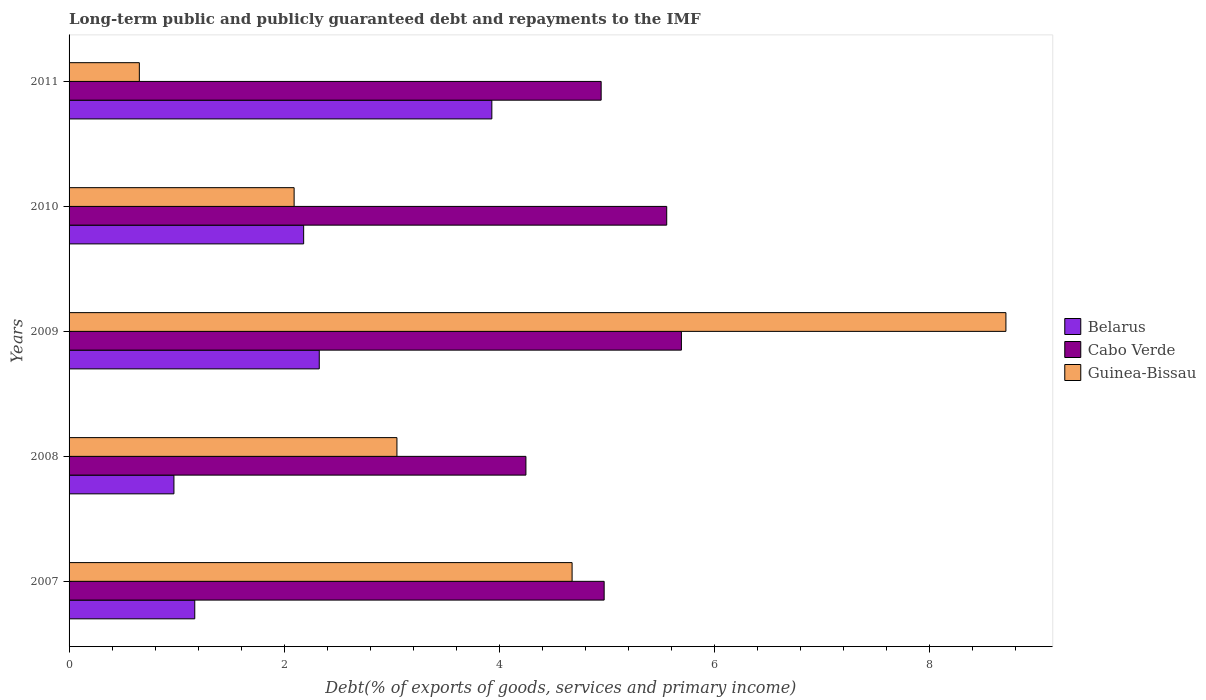How many different coloured bars are there?
Your answer should be compact. 3. How many groups of bars are there?
Ensure brevity in your answer.  5. Are the number of bars per tick equal to the number of legend labels?
Provide a succinct answer. Yes. In how many cases, is the number of bars for a given year not equal to the number of legend labels?
Keep it short and to the point. 0. What is the debt and repayments in Guinea-Bissau in 2007?
Keep it short and to the point. 4.68. Across all years, what is the maximum debt and repayments in Belarus?
Offer a very short reply. 3.93. Across all years, what is the minimum debt and repayments in Cabo Verde?
Your answer should be very brief. 4.25. In which year was the debt and repayments in Belarus maximum?
Make the answer very short. 2011. In which year was the debt and repayments in Belarus minimum?
Your response must be concise. 2008. What is the total debt and repayments in Belarus in the graph?
Provide a short and direct response. 10.58. What is the difference between the debt and repayments in Cabo Verde in 2010 and that in 2011?
Keep it short and to the point. 0.61. What is the difference between the debt and repayments in Cabo Verde in 2011 and the debt and repayments in Guinea-Bissau in 2008?
Give a very brief answer. 1.9. What is the average debt and repayments in Cabo Verde per year?
Ensure brevity in your answer.  5.08. In the year 2011, what is the difference between the debt and repayments in Belarus and debt and repayments in Guinea-Bissau?
Give a very brief answer. 3.28. In how many years, is the debt and repayments in Guinea-Bissau greater than 1.6 %?
Make the answer very short. 4. What is the ratio of the debt and repayments in Cabo Verde in 2007 to that in 2009?
Your answer should be very brief. 0.87. What is the difference between the highest and the second highest debt and repayments in Belarus?
Your answer should be compact. 1.6. What is the difference between the highest and the lowest debt and repayments in Belarus?
Make the answer very short. 2.96. In how many years, is the debt and repayments in Belarus greater than the average debt and repayments in Belarus taken over all years?
Offer a very short reply. 3. What does the 2nd bar from the top in 2008 represents?
Give a very brief answer. Cabo Verde. What does the 3rd bar from the bottom in 2007 represents?
Your answer should be very brief. Guinea-Bissau. How many bars are there?
Keep it short and to the point. 15. How many years are there in the graph?
Give a very brief answer. 5. Are the values on the major ticks of X-axis written in scientific E-notation?
Give a very brief answer. No. Does the graph contain any zero values?
Your response must be concise. No. Does the graph contain grids?
Keep it short and to the point. No. How many legend labels are there?
Provide a succinct answer. 3. What is the title of the graph?
Offer a very short reply. Long-term public and publicly guaranteed debt and repayments to the IMF. Does "United Kingdom" appear as one of the legend labels in the graph?
Your response must be concise. No. What is the label or title of the X-axis?
Your answer should be compact. Debt(% of exports of goods, services and primary income). What is the Debt(% of exports of goods, services and primary income) of Belarus in 2007?
Ensure brevity in your answer.  1.17. What is the Debt(% of exports of goods, services and primary income) in Cabo Verde in 2007?
Your answer should be very brief. 4.97. What is the Debt(% of exports of goods, services and primary income) in Guinea-Bissau in 2007?
Offer a terse response. 4.68. What is the Debt(% of exports of goods, services and primary income) in Belarus in 2008?
Provide a succinct answer. 0.98. What is the Debt(% of exports of goods, services and primary income) in Cabo Verde in 2008?
Give a very brief answer. 4.25. What is the Debt(% of exports of goods, services and primary income) in Guinea-Bissau in 2008?
Provide a short and direct response. 3.05. What is the Debt(% of exports of goods, services and primary income) in Belarus in 2009?
Your response must be concise. 2.33. What is the Debt(% of exports of goods, services and primary income) of Cabo Verde in 2009?
Your answer should be compact. 5.69. What is the Debt(% of exports of goods, services and primary income) in Guinea-Bissau in 2009?
Provide a short and direct response. 8.71. What is the Debt(% of exports of goods, services and primary income) of Belarus in 2010?
Ensure brevity in your answer.  2.18. What is the Debt(% of exports of goods, services and primary income) of Cabo Verde in 2010?
Ensure brevity in your answer.  5.56. What is the Debt(% of exports of goods, services and primary income) of Guinea-Bissau in 2010?
Ensure brevity in your answer.  2.09. What is the Debt(% of exports of goods, services and primary income) in Belarus in 2011?
Give a very brief answer. 3.93. What is the Debt(% of exports of goods, services and primary income) of Cabo Verde in 2011?
Offer a terse response. 4.95. What is the Debt(% of exports of goods, services and primary income) of Guinea-Bissau in 2011?
Provide a succinct answer. 0.65. Across all years, what is the maximum Debt(% of exports of goods, services and primary income) in Belarus?
Provide a short and direct response. 3.93. Across all years, what is the maximum Debt(% of exports of goods, services and primary income) of Cabo Verde?
Make the answer very short. 5.69. Across all years, what is the maximum Debt(% of exports of goods, services and primary income) in Guinea-Bissau?
Give a very brief answer. 8.71. Across all years, what is the minimum Debt(% of exports of goods, services and primary income) in Belarus?
Make the answer very short. 0.98. Across all years, what is the minimum Debt(% of exports of goods, services and primary income) of Cabo Verde?
Your answer should be compact. 4.25. Across all years, what is the minimum Debt(% of exports of goods, services and primary income) of Guinea-Bissau?
Offer a terse response. 0.65. What is the total Debt(% of exports of goods, services and primary income) in Belarus in the graph?
Offer a terse response. 10.58. What is the total Debt(% of exports of goods, services and primary income) of Cabo Verde in the graph?
Make the answer very short. 25.42. What is the total Debt(% of exports of goods, services and primary income) of Guinea-Bissau in the graph?
Provide a succinct answer. 19.18. What is the difference between the Debt(% of exports of goods, services and primary income) of Belarus in 2007 and that in 2008?
Your answer should be compact. 0.19. What is the difference between the Debt(% of exports of goods, services and primary income) in Cabo Verde in 2007 and that in 2008?
Your answer should be compact. 0.73. What is the difference between the Debt(% of exports of goods, services and primary income) of Guinea-Bissau in 2007 and that in 2008?
Ensure brevity in your answer.  1.63. What is the difference between the Debt(% of exports of goods, services and primary income) in Belarus in 2007 and that in 2009?
Make the answer very short. -1.16. What is the difference between the Debt(% of exports of goods, services and primary income) in Cabo Verde in 2007 and that in 2009?
Give a very brief answer. -0.72. What is the difference between the Debt(% of exports of goods, services and primary income) in Guinea-Bissau in 2007 and that in 2009?
Provide a succinct answer. -4.03. What is the difference between the Debt(% of exports of goods, services and primary income) of Belarus in 2007 and that in 2010?
Your answer should be very brief. -1.01. What is the difference between the Debt(% of exports of goods, services and primary income) of Cabo Verde in 2007 and that in 2010?
Offer a terse response. -0.58. What is the difference between the Debt(% of exports of goods, services and primary income) of Guinea-Bissau in 2007 and that in 2010?
Keep it short and to the point. 2.58. What is the difference between the Debt(% of exports of goods, services and primary income) in Belarus in 2007 and that in 2011?
Your answer should be very brief. -2.76. What is the difference between the Debt(% of exports of goods, services and primary income) of Cabo Verde in 2007 and that in 2011?
Provide a short and direct response. 0.03. What is the difference between the Debt(% of exports of goods, services and primary income) in Guinea-Bissau in 2007 and that in 2011?
Your answer should be very brief. 4.02. What is the difference between the Debt(% of exports of goods, services and primary income) of Belarus in 2008 and that in 2009?
Offer a very short reply. -1.35. What is the difference between the Debt(% of exports of goods, services and primary income) in Cabo Verde in 2008 and that in 2009?
Provide a succinct answer. -1.45. What is the difference between the Debt(% of exports of goods, services and primary income) of Guinea-Bissau in 2008 and that in 2009?
Provide a succinct answer. -5.66. What is the difference between the Debt(% of exports of goods, services and primary income) of Belarus in 2008 and that in 2010?
Provide a succinct answer. -1.21. What is the difference between the Debt(% of exports of goods, services and primary income) in Cabo Verde in 2008 and that in 2010?
Your response must be concise. -1.31. What is the difference between the Debt(% of exports of goods, services and primary income) in Guinea-Bissau in 2008 and that in 2010?
Provide a succinct answer. 0.96. What is the difference between the Debt(% of exports of goods, services and primary income) of Belarus in 2008 and that in 2011?
Offer a terse response. -2.96. What is the difference between the Debt(% of exports of goods, services and primary income) of Cabo Verde in 2008 and that in 2011?
Your response must be concise. -0.7. What is the difference between the Debt(% of exports of goods, services and primary income) of Guinea-Bissau in 2008 and that in 2011?
Your answer should be very brief. 2.39. What is the difference between the Debt(% of exports of goods, services and primary income) of Belarus in 2009 and that in 2010?
Your response must be concise. 0.15. What is the difference between the Debt(% of exports of goods, services and primary income) in Cabo Verde in 2009 and that in 2010?
Your answer should be compact. 0.14. What is the difference between the Debt(% of exports of goods, services and primary income) in Guinea-Bissau in 2009 and that in 2010?
Your response must be concise. 6.62. What is the difference between the Debt(% of exports of goods, services and primary income) of Belarus in 2009 and that in 2011?
Make the answer very short. -1.6. What is the difference between the Debt(% of exports of goods, services and primary income) of Cabo Verde in 2009 and that in 2011?
Make the answer very short. 0.75. What is the difference between the Debt(% of exports of goods, services and primary income) in Guinea-Bissau in 2009 and that in 2011?
Make the answer very short. 8.06. What is the difference between the Debt(% of exports of goods, services and primary income) in Belarus in 2010 and that in 2011?
Your answer should be very brief. -1.75. What is the difference between the Debt(% of exports of goods, services and primary income) in Cabo Verde in 2010 and that in 2011?
Give a very brief answer. 0.61. What is the difference between the Debt(% of exports of goods, services and primary income) in Guinea-Bissau in 2010 and that in 2011?
Provide a succinct answer. 1.44. What is the difference between the Debt(% of exports of goods, services and primary income) in Belarus in 2007 and the Debt(% of exports of goods, services and primary income) in Cabo Verde in 2008?
Keep it short and to the point. -3.08. What is the difference between the Debt(% of exports of goods, services and primary income) of Belarus in 2007 and the Debt(% of exports of goods, services and primary income) of Guinea-Bissau in 2008?
Offer a very short reply. -1.88. What is the difference between the Debt(% of exports of goods, services and primary income) in Cabo Verde in 2007 and the Debt(% of exports of goods, services and primary income) in Guinea-Bissau in 2008?
Your response must be concise. 1.93. What is the difference between the Debt(% of exports of goods, services and primary income) in Belarus in 2007 and the Debt(% of exports of goods, services and primary income) in Cabo Verde in 2009?
Provide a short and direct response. -4.52. What is the difference between the Debt(% of exports of goods, services and primary income) of Belarus in 2007 and the Debt(% of exports of goods, services and primary income) of Guinea-Bissau in 2009?
Offer a very short reply. -7.54. What is the difference between the Debt(% of exports of goods, services and primary income) of Cabo Verde in 2007 and the Debt(% of exports of goods, services and primary income) of Guinea-Bissau in 2009?
Offer a very short reply. -3.74. What is the difference between the Debt(% of exports of goods, services and primary income) of Belarus in 2007 and the Debt(% of exports of goods, services and primary income) of Cabo Verde in 2010?
Make the answer very short. -4.39. What is the difference between the Debt(% of exports of goods, services and primary income) in Belarus in 2007 and the Debt(% of exports of goods, services and primary income) in Guinea-Bissau in 2010?
Make the answer very short. -0.92. What is the difference between the Debt(% of exports of goods, services and primary income) in Cabo Verde in 2007 and the Debt(% of exports of goods, services and primary income) in Guinea-Bissau in 2010?
Give a very brief answer. 2.88. What is the difference between the Debt(% of exports of goods, services and primary income) in Belarus in 2007 and the Debt(% of exports of goods, services and primary income) in Cabo Verde in 2011?
Your response must be concise. -3.78. What is the difference between the Debt(% of exports of goods, services and primary income) in Belarus in 2007 and the Debt(% of exports of goods, services and primary income) in Guinea-Bissau in 2011?
Provide a succinct answer. 0.52. What is the difference between the Debt(% of exports of goods, services and primary income) of Cabo Verde in 2007 and the Debt(% of exports of goods, services and primary income) of Guinea-Bissau in 2011?
Make the answer very short. 4.32. What is the difference between the Debt(% of exports of goods, services and primary income) of Belarus in 2008 and the Debt(% of exports of goods, services and primary income) of Cabo Verde in 2009?
Offer a terse response. -4.72. What is the difference between the Debt(% of exports of goods, services and primary income) in Belarus in 2008 and the Debt(% of exports of goods, services and primary income) in Guinea-Bissau in 2009?
Offer a very short reply. -7.74. What is the difference between the Debt(% of exports of goods, services and primary income) in Cabo Verde in 2008 and the Debt(% of exports of goods, services and primary income) in Guinea-Bissau in 2009?
Your answer should be very brief. -4.46. What is the difference between the Debt(% of exports of goods, services and primary income) of Belarus in 2008 and the Debt(% of exports of goods, services and primary income) of Cabo Verde in 2010?
Keep it short and to the point. -4.58. What is the difference between the Debt(% of exports of goods, services and primary income) in Belarus in 2008 and the Debt(% of exports of goods, services and primary income) in Guinea-Bissau in 2010?
Provide a short and direct response. -1.12. What is the difference between the Debt(% of exports of goods, services and primary income) in Cabo Verde in 2008 and the Debt(% of exports of goods, services and primary income) in Guinea-Bissau in 2010?
Offer a very short reply. 2.15. What is the difference between the Debt(% of exports of goods, services and primary income) of Belarus in 2008 and the Debt(% of exports of goods, services and primary income) of Cabo Verde in 2011?
Keep it short and to the point. -3.97. What is the difference between the Debt(% of exports of goods, services and primary income) of Belarus in 2008 and the Debt(% of exports of goods, services and primary income) of Guinea-Bissau in 2011?
Give a very brief answer. 0.32. What is the difference between the Debt(% of exports of goods, services and primary income) of Cabo Verde in 2008 and the Debt(% of exports of goods, services and primary income) of Guinea-Bissau in 2011?
Give a very brief answer. 3.59. What is the difference between the Debt(% of exports of goods, services and primary income) of Belarus in 2009 and the Debt(% of exports of goods, services and primary income) of Cabo Verde in 2010?
Offer a terse response. -3.23. What is the difference between the Debt(% of exports of goods, services and primary income) of Belarus in 2009 and the Debt(% of exports of goods, services and primary income) of Guinea-Bissau in 2010?
Your answer should be very brief. 0.23. What is the difference between the Debt(% of exports of goods, services and primary income) of Cabo Verde in 2009 and the Debt(% of exports of goods, services and primary income) of Guinea-Bissau in 2010?
Your answer should be very brief. 3.6. What is the difference between the Debt(% of exports of goods, services and primary income) of Belarus in 2009 and the Debt(% of exports of goods, services and primary income) of Cabo Verde in 2011?
Your response must be concise. -2.62. What is the difference between the Debt(% of exports of goods, services and primary income) of Belarus in 2009 and the Debt(% of exports of goods, services and primary income) of Guinea-Bissau in 2011?
Offer a very short reply. 1.67. What is the difference between the Debt(% of exports of goods, services and primary income) of Cabo Verde in 2009 and the Debt(% of exports of goods, services and primary income) of Guinea-Bissau in 2011?
Offer a terse response. 5.04. What is the difference between the Debt(% of exports of goods, services and primary income) in Belarus in 2010 and the Debt(% of exports of goods, services and primary income) in Cabo Verde in 2011?
Give a very brief answer. -2.77. What is the difference between the Debt(% of exports of goods, services and primary income) of Belarus in 2010 and the Debt(% of exports of goods, services and primary income) of Guinea-Bissau in 2011?
Your response must be concise. 1.53. What is the difference between the Debt(% of exports of goods, services and primary income) in Cabo Verde in 2010 and the Debt(% of exports of goods, services and primary income) in Guinea-Bissau in 2011?
Your answer should be compact. 4.9. What is the average Debt(% of exports of goods, services and primary income) of Belarus per year?
Your answer should be compact. 2.12. What is the average Debt(% of exports of goods, services and primary income) of Cabo Verde per year?
Your answer should be very brief. 5.08. What is the average Debt(% of exports of goods, services and primary income) in Guinea-Bissau per year?
Your answer should be very brief. 3.84. In the year 2007, what is the difference between the Debt(% of exports of goods, services and primary income) of Belarus and Debt(% of exports of goods, services and primary income) of Cabo Verde?
Provide a short and direct response. -3.81. In the year 2007, what is the difference between the Debt(% of exports of goods, services and primary income) in Belarus and Debt(% of exports of goods, services and primary income) in Guinea-Bissau?
Provide a short and direct response. -3.51. In the year 2007, what is the difference between the Debt(% of exports of goods, services and primary income) of Cabo Verde and Debt(% of exports of goods, services and primary income) of Guinea-Bissau?
Ensure brevity in your answer.  0.3. In the year 2008, what is the difference between the Debt(% of exports of goods, services and primary income) in Belarus and Debt(% of exports of goods, services and primary income) in Cabo Verde?
Ensure brevity in your answer.  -3.27. In the year 2008, what is the difference between the Debt(% of exports of goods, services and primary income) in Belarus and Debt(% of exports of goods, services and primary income) in Guinea-Bissau?
Your answer should be compact. -2.07. In the year 2008, what is the difference between the Debt(% of exports of goods, services and primary income) of Cabo Verde and Debt(% of exports of goods, services and primary income) of Guinea-Bissau?
Provide a succinct answer. 1.2. In the year 2009, what is the difference between the Debt(% of exports of goods, services and primary income) in Belarus and Debt(% of exports of goods, services and primary income) in Cabo Verde?
Offer a very short reply. -3.37. In the year 2009, what is the difference between the Debt(% of exports of goods, services and primary income) of Belarus and Debt(% of exports of goods, services and primary income) of Guinea-Bissau?
Make the answer very short. -6.38. In the year 2009, what is the difference between the Debt(% of exports of goods, services and primary income) of Cabo Verde and Debt(% of exports of goods, services and primary income) of Guinea-Bissau?
Offer a terse response. -3.02. In the year 2010, what is the difference between the Debt(% of exports of goods, services and primary income) of Belarus and Debt(% of exports of goods, services and primary income) of Cabo Verde?
Provide a short and direct response. -3.38. In the year 2010, what is the difference between the Debt(% of exports of goods, services and primary income) in Belarus and Debt(% of exports of goods, services and primary income) in Guinea-Bissau?
Offer a terse response. 0.09. In the year 2010, what is the difference between the Debt(% of exports of goods, services and primary income) of Cabo Verde and Debt(% of exports of goods, services and primary income) of Guinea-Bissau?
Keep it short and to the point. 3.46. In the year 2011, what is the difference between the Debt(% of exports of goods, services and primary income) in Belarus and Debt(% of exports of goods, services and primary income) in Cabo Verde?
Your response must be concise. -1.02. In the year 2011, what is the difference between the Debt(% of exports of goods, services and primary income) of Belarus and Debt(% of exports of goods, services and primary income) of Guinea-Bissau?
Make the answer very short. 3.28. In the year 2011, what is the difference between the Debt(% of exports of goods, services and primary income) in Cabo Verde and Debt(% of exports of goods, services and primary income) in Guinea-Bissau?
Keep it short and to the point. 4.29. What is the ratio of the Debt(% of exports of goods, services and primary income) in Belarus in 2007 to that in 2008?
Ensure brevity in your answer.  1.2. What is the ratio of the Debt(% of exports of goods, services and primary income) in Cabo Verde in 2007 to that in 2008?
Offer a terse response. 1.17. What is the ratio of the Debt(% of exports of goods, services and primary income) in Guinea-Bissau in 2007 to that in 2008?
Keep it short and to the point. 1.53. What is the ratio of the Debt(% of exports of goods, services and primary income) in Belarus in 2007 to that in 2009?
Ensure brevity in your answer.  0.5. What is the ratio of the Debt(% of exports of goods, services and primary income) in Cabo Verde in 2007 to that in 2009?
Keep it short and to the point. 0.87. What is the ratio of the Debt(% of exports of goods, services and primary income) of Guinea-Bissau in 2007 to that in 2009?
Make the answer very short. 0.54. What is the ratio of the Debt(% of exports of goods, services and primary income) of Belarus in 2007 to that in 2010?
Your answer should be very brief. 0.54. What is the ratio of the Debt(% of exports of goods, services and primary income) of Cabo Verde in 2007 to that in 2010?
Provide a succinct answer. 0.9. What is the ratio of the Debt(% of exports of goods, services and primary income) of Guinea-Bissau in 2007 to that in 2010?
Offer a terse response. 2.24. What is the ratio of the Debt(% of exports of goods, services and primary income) of Belarus in 2007 to that in 2011?
Offer a terse response. 0.3. What is the ratio of the Debt(% of exports of goods, services and primary income) of Cabo Verde in 2007 to that in 2011?
Keep it short and to the point. 1.01. What is the ratio of the Debt(% of exports of goods, services and primary income) of Guinea-Bissau in 2007 to that in 2011?
Your answer should be very brief. 7.16. What is the ratio of the Debt(% of exports of goods, services and primary income) in Belarus in 2008 to that in 2009?
Keep it short and to the point. 0.42. What is the ratio of the Debt(% of exports of goods, services and primary income) of Cabo Verde in 2008 to that in 2009?
Offer a terse response. 0.75. What is the ratio of the Debt(% of exports of goods, services and primary income) in Guinea-Bissau in 2008 to that in 2009?
Keep it short and to the point. 0.35. What is the ratio of the Debt(% of exports of goods, services and primary income) of Belarus in 2008 to that in 2010?
Your response must be concise. 0.45. What is the ratio of the Debt(% of exports of goods, services and primary income) in Cabo Verde in 2008 to that in 2010?
Keep it short and to the point. 0.76. What is the ratio of the Debt(% of exports of goods, services and primary income) in Guinea-Bissau in 2008 to that in 2010?
Keep it short and to the point. 1.46. What is the ratio of the Debt(% of exports of goods, services and primary income) in Belarus in 2008 to that in 2011?
Keep it short and to the point. 0.25. What is the ratio of the Debt(% of exports of goods, services and primary income) in Cabo Verde in 2008 to that in 2011?
Your answer should be very brief. 0.86. What is the ratio of the Debt(% of exports of goods, services and primary income) of Guinea-Bissau in 2008 to that in 2011?
Keep it short and to the point. 4.67. What is the ratio of the Debt(% of exports of goods, services and primary income) of Belarus in 2009 to that in 2010?
Your answer should be very brief. 1.07. What is the ratio of the Debt(% of exports of goods, services and primary income) of Cabo Verde in 2009 to that in 2010?
Provide a short and direct response. 1.02. What is the ratio of the Debt(% of exports of goods, services and primary income) of Guinea-Bissau in 2009 to that in 2010?
Make the answer very short. 4.16. What is the ratio of the Debt(% of exports of goods, services and primary income) of Belarus in 2009 to that in 2011?
Give a very brief answer. 0.59. What is the ratio of the Debt(% of exports of goods, services and primary income) in Cabo Verde in 2009 to that in 2011?
Make the answer very short. 1.15. What is the ratio of the Debt(% of exports of goods, services and primary income) of Guinea-Bissau in 2009 to that in 2011?
Make the answer very short. 13.33. What is the ratio of the Debt(% of exports of goods, services and primary income) in Belarus in 2010 to that in 2011?
Your answer should be very brief. 0.55. What is the ratio of the Debt(% of exports of goods, services and primary income) of Cabo Verde in 2010 to that in 2011?
Your response must be concise. 1.12. What is the ratio of the Debt(% of exports of goods, services and primary income) of Guinea-Bissau in 2010 to that in 2011?
Provide a short and direct response. 3.2. What is the difference between the highest and the second highest Debt(% of exports of goods, services and primary income) in Belarus?
Provide a succinct answer. 1.6. What is the difference between the highest and the second highest Debt(% of exports of goods, services and primary income) of Cabo Verde?
Your answer should be compact. 0.14. What is the difference between the highest and the second highest Debt(% of exports of goods, services and primary income) in Guinea-Bissau?
Your answer should be compact. 4.03. What is the difference between the highest and the lowest Debt(% of exports of goods, services and primary income) of Belarus?
Make the answer very short. 2.96. What is the difference between the highest and the lowest Debt(% of exports of goods, services and primary income) of Cabo Verde?
Your answer should be compact. 1.45. What is the difference between the highest and the lowest Debt(% of exports of goods, services and primary income) in Guinea-Bissau?
Offer a very short reply. 8.06. 